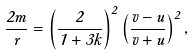<formula> <loc_0><loc_0><loc_500><loc_500>\frac { 2 m } { r } = \left ( \frac { 2 } { 1 + 3 k } \right ) ^ { 2 } \left ( \frac { v - u } { v + u } \right ) ^ { 2 } ,</formula> 